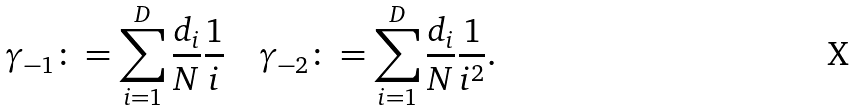<formula> <loc_0><loc_0><loc_500><loc_500>\gamma _ { - 1 } \colon = \sum _ { i = 1 } ^ { D } { \frac { d _ { i } } { N } \frac { 1 } { i } } \quad \gamma _ { - 2 } \colon = \sum _ { i = 1 } ^ { D } { \frac { d _ { i } } { N } \frac { 1 } { i ^ { 2 } } } .</formula> 